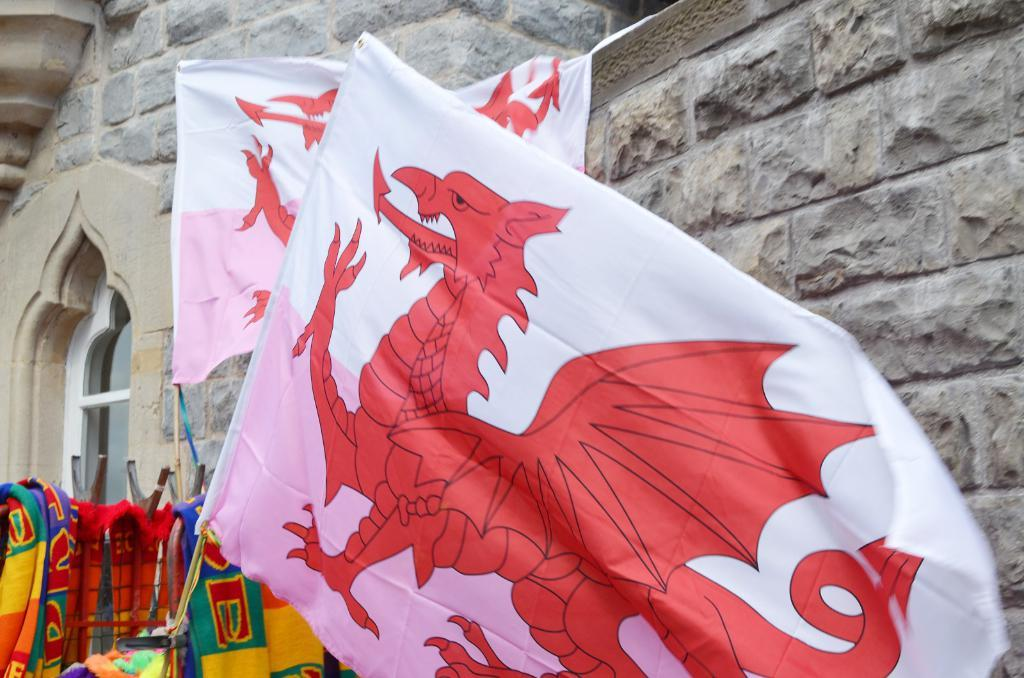What are the flags attached to in the image? The flags are hanging on wooden sticks. What type of clothing can be seen in the image? There are colorful clothes visible. What type of structure can be seen in the image? There appears to be a building in the image. Is there any indication of an entrance in the image? There might be a glass door in the image, which could be an entrance. What architectural feature is present in the image? There is an arch present in the image. Can you see any snails crawling on the colorful clothes in the image? There are no snails visible in the image. Is the grandmother sitting on the steps of the building in the image? There is no mention of a grandmother or any person sitting in the image. Are there any worms crawling on the wooden sticks holding the flags in the image? There are no worms visible in the image. 